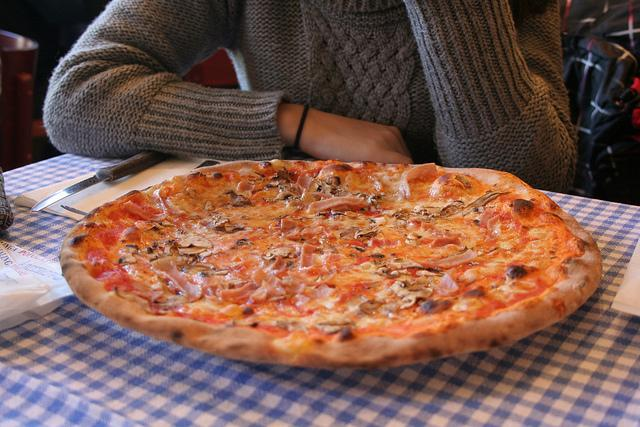How many distinct topping types are on this pizza?

Choices:
A) two
B) one
C) four
D) three two 